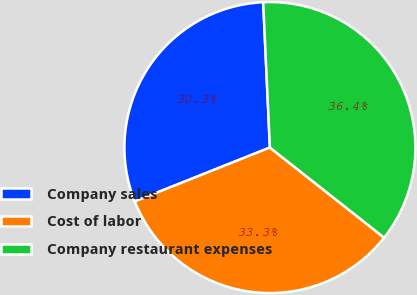Convert chart. <chart><loc_0><loc_0><loc_500><loc_500><pie_chart><fcel>Company sales<fcel>Cost of labor<fcel>Company restaurant expenses<nl><fcel>30.3%<fcel>33.33%<fcel>36.36%<nl></chart> 